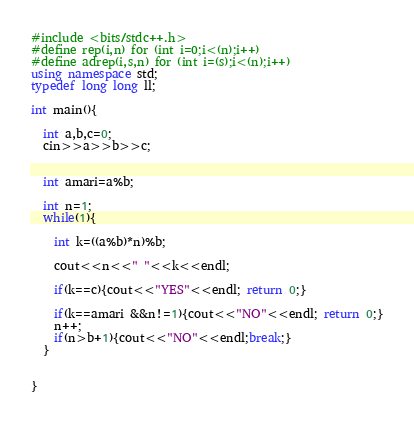<code> <loc_0><loc_0><loc_500><loc_500><_C++_>#include <bits/stdc++.h>
#define rep(i,n) for (int i=0;i<(n);i++)
#define adrep(i,s,n) for (int i=(s);i<(n);i++)
using namespace std;
typedef long long ll;

int main(){

  int a,b,c=0;
  cin>>a>>b>>c;
	

  int amari=a%b;
  
  int n=1;
  while(1){

	int k=((a%b)*n)%b;
    
    cout<<n<<" "<<k<<endl;
    
    if(k==c){cout<<"YES"<<endl; return 0;}

    if(k==amari &&n!=1){cout<<"NO"<<endl; return 0;}
    n++;
    if(n>b+1){cout<<"NO"<<endl;break;}
  }
  
  
}
</code> 